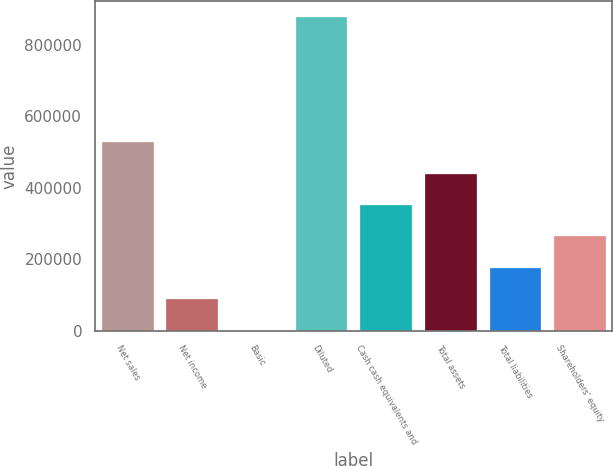<chart> <loc_0><loc_0><loc_500><loc_500><bar_chart><fcel>Net sales<fcel>Net income<fcel>Basic<fcel>Diluted<fcel>Cash cash equivalents and<fcel>Total assets<fcel>Total liabilities<fcel>Shareholders' equity<nl><fcel>526517<fcel>87754.7<fcel>2.36<fcel>877526<fcel>351012<fcel>438764<fcel>175507<fcel>263259<nl></chart> 